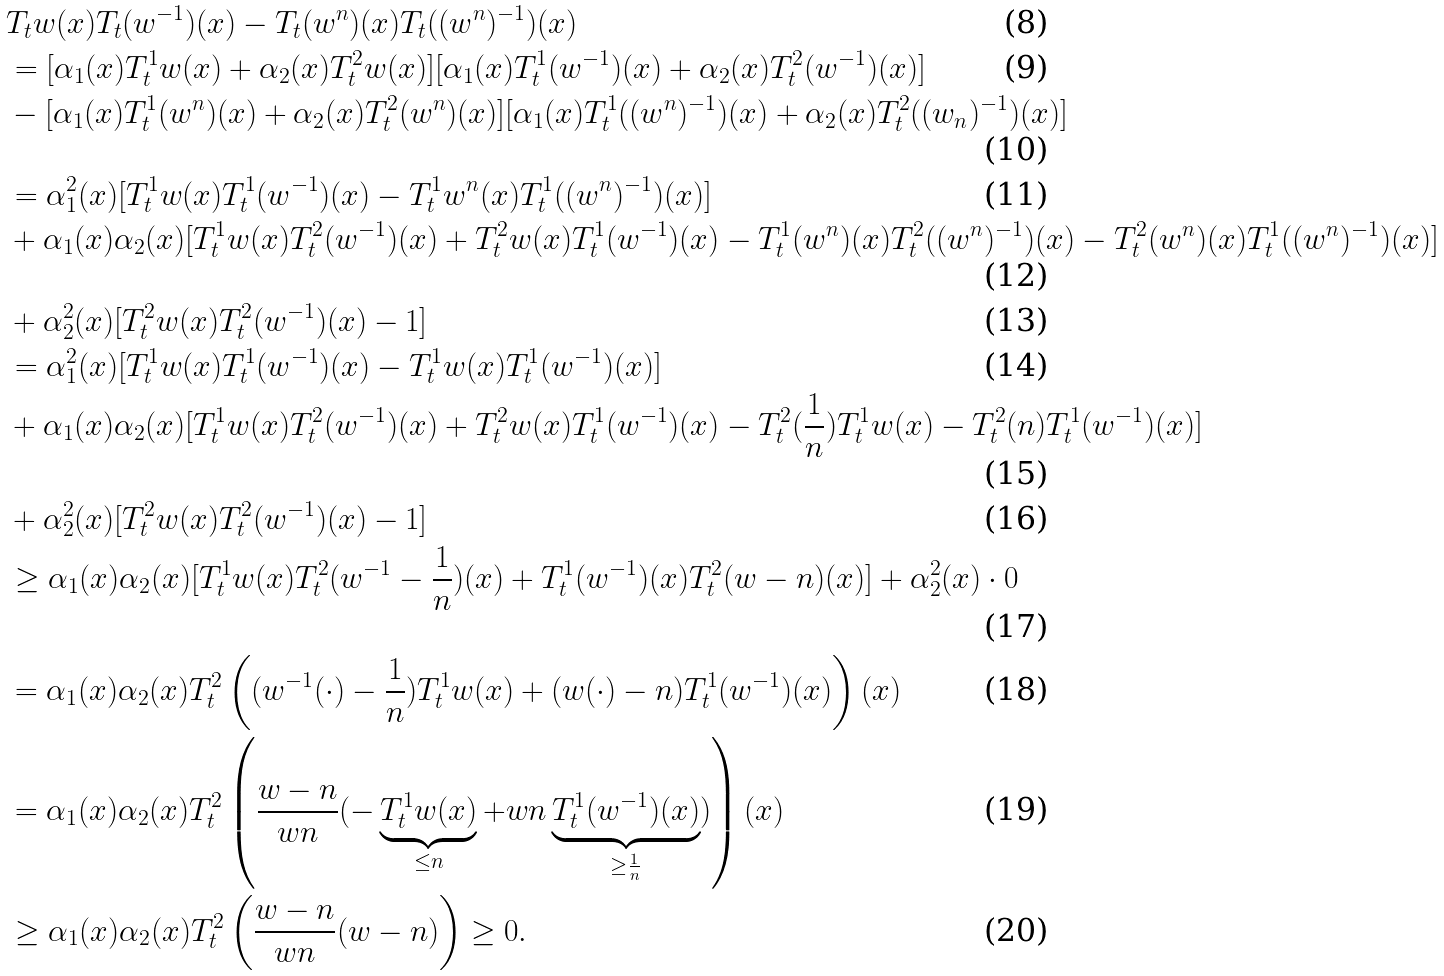<formula> <loc_0><loc_0><loc_500><loc_500>& T _ { t } w ( x ) T _ { t } ( w ^ { - 1 } ) ( x ) - T _ { t } ( w ^ { n } ) ( x ) T _ { t } ( ( w ^ { n } ) ^ { - 1 } ) ( x ) \\ & = [ \alpha _ { 1 } ( x ) T _ { t } ^ { 1 } w ( x ) + \alpha _ { 2 } ( x ) T _ { t } ^ { 2 } w ( x ) ] [ \alpha _ { 1 } ( x ) T _ { t } ^ { 1 } ( w ^ { - 1 } ) ( x ) + \alpha _ { 2 } ( x ) T _ { t } ^ { 2 } ( w ^ { - 1 } ) ( x ) ] \\ & - [ \alpha _ { 1 } ( x ) T _ { t } ^ { 1 } ( w ^ { n } ) ( x ) + \alpha _ { 2 } ( x ) T _ { t } ^ { 2 } ( w ^ { n } ) ( x ) ] [ \alpha _ { 1 } ( x ) T _ { t } ^ { 1 } ( ( w ^ { n } ) ^ { - 1 } ) ( x ) + \alpha _ { 2 } ( x ) T _ { t } ^ { 2 } ( ( w _ { n } ) ^ { - 1 } ) ( x ) ] \\ & = \alpha _ { 1 } ^ { 2 } ( x ) [ T _ { t } ^ { 1 } w ( x ) T _ { t } ^ { 1 } ( w ^ { - 1 } ) ( x ) - T _ { t } ^ { 1 } w ^ { n } ( x ) T _ { t } ^ { 1 } ( ( w ^ { n } ) ^ { - 1 } ) ( x ) ] \\ & + \alpha _ { 1 } ( x ) \alpha _ { 2 } ( x ) [ T _ { t } ^ { 1 } w ( x ) T _ { t } ^ { 2 } ( w ^ { - 1 } ) ( x ) + T _ { t } ^ { 2 } w ( x ) T _ { t } ^ { 1 } ( w ^ { - 1 } ) ( x ) - T _ { t } ^ { 1 } ( w ^ { n } ) ( x ) T _ { t } ^ { 2 } ( ( w ^ { n } ) ^ { - 1 } ) ( x ) - T _ { t } ^ { 2 } ( w ^ { n } ) ( x ) T _ { t } ^ { 1 } ( ( w ^ { n } ) ^ { - 1 } ) ( x ) ] \\ & + \alpha _ { 2 } ^ { 2 } ( x ) [ T _ { t } ^ { 2 } w ( x ) T _ { t } ^ { 2 } ( w ^ { - 1 } ) ( x ) - 1 ] \\ & = \alpha _ { 1 } ^ { 2 } ( x ) [ T _ { t } ^ { 1 } w ( x ) T _ { t } ^ { 1 } ( w ^ { - 1 } ) ( x ) - T _ { t } ^ { 1 } w ( x ) T _ { t } ^ { 1 } ( w ^ { - 1 } ) ( x ) ] \\ & + \alpha _ { 1 } ( x ) \alpha _ { 2 } ( x ) [ T _ { t } ^ { 1 } w ( x ) T _ { t } ^ { 2 } ( w ^ { - 1 } ) ( x ) + T _ { t } ^ { 2 } w ( x ) T _ { t } ^ { 1 } ( w ^ { - 1 } ) ( x ) - T _ { t } ^ { 2 } ( \frac { 1 } { n } ) T _ { t } ^ { 1 } w ( x ) - T _ { t } ^ { 2 } ( n ) T _ { t } ^ { 1 } ( w ^ { - 1 } ) ( x ) ] \\ & + \alpha _ { 2 } ^ { 2 } ( x ) [ T _ { t } ^ { 2 } w ( x ) T _ { t } ^ { 2 } ( w ^ { - 1 } ) ( x ) - 1 ] \\ & \geq \alpha _ { 1 } ( x ) \alpha _ { 2 } ( x ) [ T _ { t } ^ { 1 } w ( x ) T _ { t } ^ { 2 } ( w ^ { - 1 } - \frac { 1 } { n } ) ( x ) + T _ { t } ^ { 1 } ( w ^ { - 1 } ) ( x ) T _ { t } ^ { 2 } ( w - n ) ( x ) ] + \alpha _ { 2 } ^ { 2 } ( x ) \cdot 0 \\ & = \alpha _ { 1 } ( x ) \alpha _ { 2 } ( x ) T _ { t } ^ { 2 } \left ( ( w ^ { - 1 } ( \cdot ) - \frac { 1 } { n } ) T _ { t } ^ { 1 } w ( x ) + ( w ( \cdot ) - n ) T _ { t } ^ { 1 } ( w ^ { - 1 } ) ( x ) \right ) ( x ) \\ & = \alpha _ { 1 } ( x ) \alpha _ { 2 } ( x ) T _ { t } ^ { 2 } \left ( \frac { w - n } { w n } ( - \underbrace { T _ { t } ^ { 1 } w ( x ) } _ { \leq n } + w n \underbrace { T _ { t } ^ { 1 } ( w ^ { - 1 } ) ( x ) } _ { \geq \frac { 1 } { n } } ) \right ) ( x ) \\ & \geq \alpha _ { 1 } ( x ) \alpha _ { 2 } ( x ) T _ { t } ^ { 2 } \left ( \frac { w - n } { w n } ( w - n ) \right ) \geq 0 .</formula> 